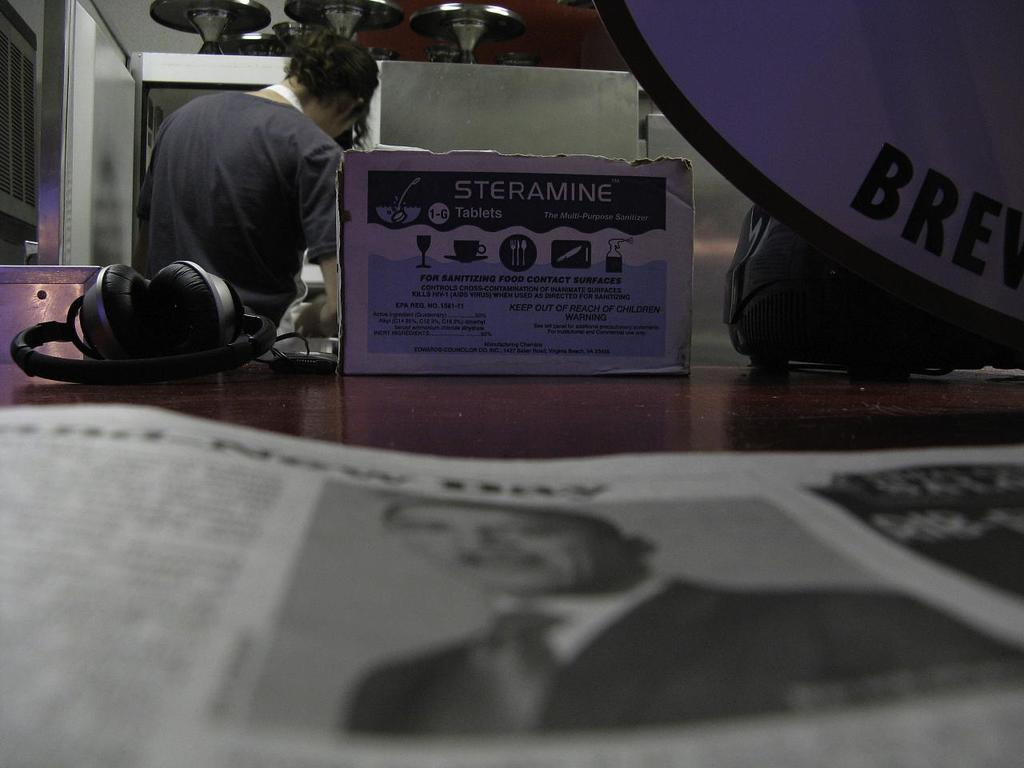What is placed on the table in the image? There is a newspaper, headphones, a cardboard box, and a bag on the table. What might the person standing behind the table be holding? It is not clear from the image what the person might be holding. What can be seen on the wall on the left side of the image? There is a window on the wall on the left side of the image. What type of receipt can be seen on the table in the image? There is no receipt present on the table in the image. What time of day is it in the image, given the presence of the afternoon sun? The image does not provide any information about the time of day, and there is no mention of the sun in the provided facts. 